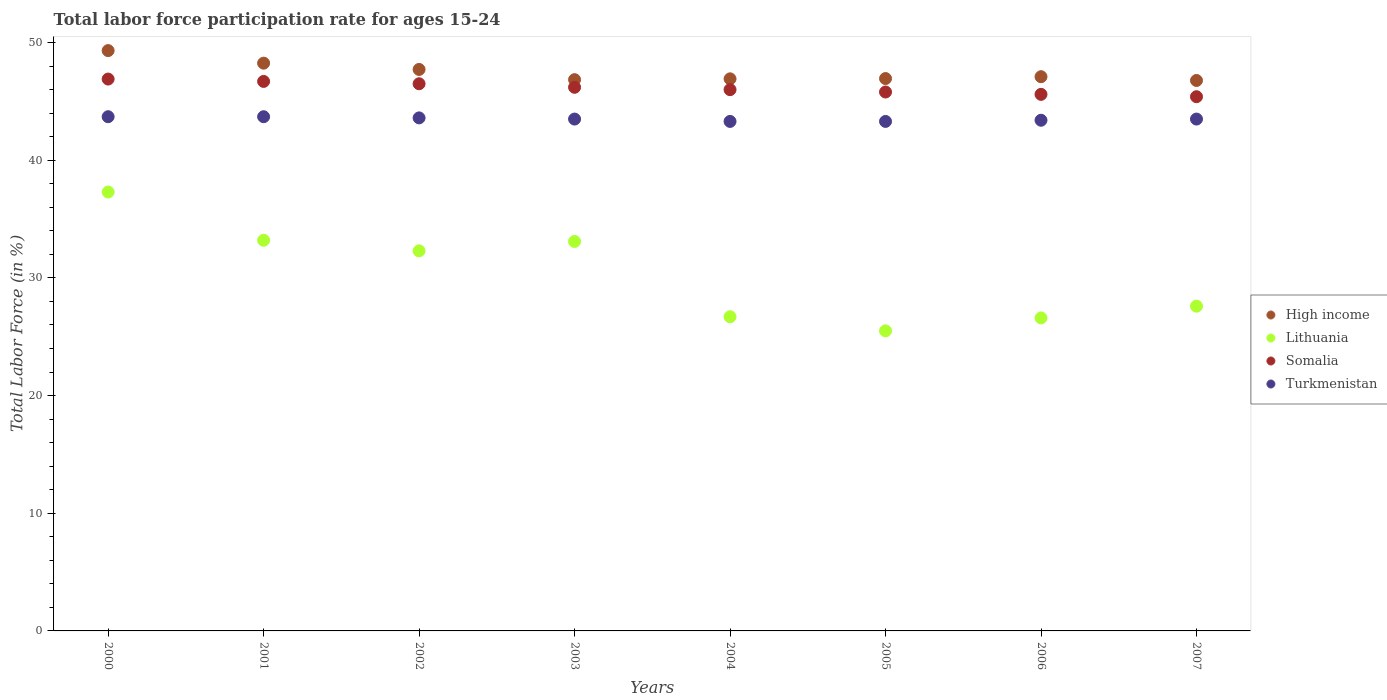Is the number of dotlines equal to the number of legend labels?
Your answer should be compact. Yes. What is the labor force participation rate in Turkmenistan in 2004?
Offer a terse response. 43.3. Across all years, what is the maximum labor force participation rate in Somalia?
Ensure brevity in your answer.  46.9. Across all years, what is the minimum labor force participation rate in Somalia?
Keep it short and to the point. 45.4. In which year was the labor force participation rate in Somalia maximum?
Ensure brevity in your answer.  2000. What is the total labor force participation rate in Lithuania in the graph?
Give a very brief answer. 242.3. What is the difference between the labor force participation rate in Lithuania in 2001 and that in 2003?
Offer a terse response. 0.1. What is the difference between the labor force participation rate in Lithuania in 2002 and the labor force participation rate in Turkmenistan in 2001?
Your response must be concise. -11.4. What is the average labor force participation rate in Somalia per year?
Give a very brief answer. 46.14. In the year 2002, what is the difference between the labor force participation rate in High income and labor force participation rate in Somalia?
Make the answer very short. 1.22. In how many years, is the labor force participation rate in High income greater than 10 %?
Keep it short and to the point. 8. What is the ratio of the labor force participation rate in Somalia in 2004 to that in 2005?
Keep it short and to the point. 1. Is the difference between the labor force participation rate in High income in 2000 and 2007 greater than the difference between the labor force participation rate in Somalia in 2000 and 2007?
Provide a succinct answer. Yes. What is the difference between the highest and the second highest labor force participation rate in Somalia?
Offer a terse response. 0.2. What is the difference between the highest and the lowest labor force participation rate in Somalia?
Keep it short and to the point. 1.5. In how many years, is the labor force participation rate in Lithuania greater than the average labor force participation rate in Lithuania taken over all years?
Provide a short and direct response. 4. Is the sum of the labor force participation rate in High income in 2004 and 2007 greater than the maximum labor force participation rate in Lithuania across all years?
Offer a terse response. Yes. Is it the case that in every year, the sum of the labor force participation rate in Somalia and labor force participation rate in Turkmenistan  is greater than the sum of labor force participation rate in Lithuania and labor force participation rate in High income?
Give a very brief answer. No. Is it the case that in every year, the sum of the labor force participation rate in High income and labor force participation rate in Turkmenistan  is greater than the labor force participation rate in Lithuania?
Make the answer very short. Yes. How many dotlines are there?
Give a very brief answer. 4. How many years are there in the graph?
Keep it short and to the point. 8. What is the difference between two consecutive major ticks on the Y-axis?
Provide a short and direct response. 10. How many legend labels are there?
Provide a succinct answer. 4. What is the title of the graph?
Your answer should be very brief. Total labor force participation rate for ages 15-24. What is the Total Labor Force (in %) of High income in 2000?
Give a very brief answer. 49.32. What is the Total Labor Force (in %) in Lithuania in 2000?
Keep it short and to the point. 37.3. What is the Total Labor Force (in %) in Somalia in 2000?
Your response must be concise. 46.9. What is the Total Labor Force (in %) in Turkmenistan in 2000?
Provide a succinct answer. 43.7. What is the Total Labor Force (in %) of High income in 2001?
Give a very brief answer. 48.25. What is the Total Labor Force (in %) of Lithuania in 2001?
Your response must be concise. 33.2. What is the Total Labor Force (in %) in Somalia in 2001?
Offer a very short reply. 46.7. What is the Total Labor Force (in %) in Turkmenistan in 2001?
Give a very brief answer. 43.7. What is the Total Labor Force (in %) in High income in 2002?
Your answer should be compact. 47.72. What is the Total Labor Force (in %) in Lithuania in 2002?
Your response must be concise. 32.3. What is the Total Labor Force (in %) of Somalia in 2002?
Provide a short and direct response. 46.5. What is the Total Labor Force (in %) in Turkmenistan in 2002?
Offer a terse response. 43.6. What is the Total Labor Force (in %) in High income in 2003?
Your answer should be very brief. 46.85. What is the Total Labor Force (in %) of Lithuania in 2003?
Your response must be concise. 33.1. What is the Total Labor Force (in %) of Somalia in 2003?
Keep it short and to the point. 46.2. What is the Total Labor Force (in %) of Turkmenistan in 2003?
Keep it short and to the point. 43.5. What is the Total Labor Force (in %) in High income in 2004?
Keep it short and to the point. 46.92. What is the Total Labor Force (in %) in Lithuania in 2004?
Offer a very short reply. 26.7. What is the Total Labor Force (in %) of Turkmenistan in 2004?
Your response must be concise. 43.3. What is the Total Labor Force (in %) of High income in 2005?
Make the answer very short. 46.94. What is the Total Labor Force (in %) of Lithuania in 2005?
Your answer should be very brief. 25.5. What is the Total Labor Force (in %) of Somalia in 2005?
Provide a succinct answer. 45.8. What is the Total Labor Force (in %) in Turkmenistan in 2005?
Your answer should be compact. 43.3. What is the Total Labor Force (in %) in High income in 2006?
Your answer should be very brief. 47.1. What is the Total Labor Force (in %) in Lithuania in 2006?
Ensure brevity in your answer.  26.6. What is the Total Labor Force (in %) of Somalia in 2006?
Your answer should be compact. 45.6. What is the Total Labor Force (in %) in Turkmenistan in 2006?
Ensure brevity in your answer.  43.4. What is the Total Labor Force (in %) of High income in 2007?
Your answer should be compact. 46.78. What is the Total Labor Force (in %) in Lithuania in 2007?
Offer a terse response. 27.6. What is the Total Labor Force (in %) in Somalia in 2007?
Your answer should be compact. 45.4. What is the Total Labor Force (in %) in Turkmenistan in 2007?
Keep it short and to the point. 43.5. Across all years, what is the maximum Total Labor Force (in %) of High income?
Ensure brevity in your answer.  49.32. Across all years, what is the maximum Total Labor Force (in %) of Lithuania?
Your answer should be very brief. 37.3. Across all years, what is the maximum Total Labor Force (in %) of Somalia?
Your answer should be very brief. 46.9. Across all years, what is the maximum Total Labor Force (in %) in Turkmenistan?
Offer a very short reply. 43.7. Across all years, what is the minimum Total Labor Force (in %) of High income?
Give a very brief answer. 46.78. Across all years, what is the minimum Total Labor Force (in %) in Lithuania?
Provide a short and direct response. 25.5. Across all years, what is the minimum Total Labor Force (in %) in Somalia?
Provide a short and direct response. 45.4. Across all years, what is the minimum Total Labor Force (in %) in Turkmenistan?
Provide a succinct answer. 43.3. What is the total Total Labor Force (in %) in High income in the graph?
Your response must be concise. 379.88. What is the total Total Labor Force (in %) of Lithuania in the graph?
Provide a short and direct response. 242.3. What is the total Total Labor Force (in %) in Somalia in the graph?
Make the answer very short. 369.1. What is the total Total Labor Force (in %) in Turkmenistan in the graph?
Your answer should be compact. 348. What is the difference between the Total Labor Force (in %) in High income in 2000 and that in 2001?
Make the answer very short. 1.07. What is the difference between the Total Labor Force (in %) in Lithuania in 2000 and that in 2001?
Make the answer very short. 4.1. What is the difference between the Total Labor Force (in %) in High income in 2000 and that in 2002?
Your answer should be very brief. 1.6. What is the difference between the Total Labor Force (in %) of Turkmenistan in 2000 and that in 2002?
Offer a very short reply. 0.1. What is the difference between the Total Labor Force (in %) in High income in 2000 and that in 2003?
Provide a short and direct response. 2.47. What is the difference between the Total Labor Force (in %) of Lithuania in 2000 and that in 2003?
Your answer should be compact. 4.2. What is the difference between the Total Labor Force (in %) in Turkmenistan in 2000 and that in 2003?
Make the answer very short. 0.2. What is the difference between the Total Labor Force (in %) in High income in 2000 and that in 2004?
Provide a succinct answer. 2.4. What is the difference between the Total Labor Force (in %) in Somalia in 2000 and that in 2004?
Ensure brevity in your answer.  0.9. What is the difference between the Total Labor Force (in %) in Turkmenistan in 2000 and that in 2004?
Ensure brevity in your answer.  0.4. What is the difference between the Total Labor Force (in %) of High income in 2000 and that in 2005?
Give a very brief answer. 2.38. What is the difference between the Total Labor Force (in %) in Lithuania in 2000 and that in 2005?
Give a very brief answer. 11.8. What is the difference between the Total Labor Force (in %) of Somalia in 2000 and that in 2005?
Ensure brevity in your answer.  1.1. What is the difference between the Total Labor Force (in %) of Turkmenistan in 2000 and that in 2005?
Ensure brevity in your answer.  0.4. What is the difference between the Total Labor Force (in %) of High income in 2000 and that in 2006?
Your answer should be compact. 2.22. What is the difference between the Total Labor Force (in %) of Turkmenistan in 2000 and that in 2006?
Your response must be concise. 0.3. What is the difference between the Total Labor Force (in %) of High income in 2000 and that in 2007?
Your answer should be compact. 2.54. What is the difference between the Total Labor Force (in %) of Lithuania in 2000 and that in 2007?
Keep it short and to the point. 9.7. What is the difference between the Total Labor Force (in %) of High income in 2001 and that in 2002?
Offer a very short reply. 0.53. What is the difference between the Total Labor Force (in %) of Lithuania in 2001 and that in 2002?
Your answer should be very brief. 0.9. What is the difference between the Total Labor Force (in %) in Turkmenistan in 2001 and that in 2002?
Offer a very short reply. 0.1. What is the difference between the Total Labor Force (in %) in High income in 2001 and that in 2003?
Provide a succinct answer. 1.4. What is the difference between the Total Labor Force (in %) of Somalia in 2001 and that in 2003?
Keep it short and to the point. 0.5. What is the difference between the Total Labor Force (in %) of High income in 2001 and that in 2004?
Your response must be concise. 1.33. What is the difference between the Total Labor Force (in %) of Lithuania in 2001 and that in 2004?
Your answer should be compact. 6.5. What is the difference between the Total Labor Force (in %) in Somalia in 2001 and that in 2004?
Give a very brief answer. 0.7. What is the difference between the Total Labor Force (in %) of Turkmenistan in 2001 and that in 2004?
Give a very brief answer. 0.4. What is the difference between the Total Labor Force (in %) in High income in 2001 and that in 2005?
Offer a very short reply. 1.31. What is the difference between the Total Labor Force (in %) of Lithuania in 2001 and that in 2005?
Offer a terse response. 7.7. What is the difference between the Total Labor Force (in %) in Somalia in 2001 and that in 2005?
Provide a succinct answer. 0.9. What is the difference between the Total Labor Force (in %) in High income in 2001 and that in 2006?
Keep it short and to the point. 1.15. What is the difference between the Total Labor Force (in %) in Lithuania in 2001 and that in 2006?
Provide a short and direct response. 6.6. What is the difference between the Total Labor Force (in %) in Somalia in 2001 and that in 2006?
Offer a very short reply. 1.1. What is the difference between the Total Labor Force (in %) in High income in 2001 and that in 2007?
Provide a short and direct response. 1.47. What is the difference between the Total Labor Force (in %) in High income in 2002 and that in 2003?
Ensure brevity in your answer.  0.87. What is the difference between the Total Labor Force (in %) of High income in 2002 and that in 2004?
Provide a succinct answer. 0.8. What is the difference between the Total Labor Force (in %) in Lithuania in 2002 and that in 2004?
Ensure brevity in your answer.  5.6. What is the difference between the Total Labor Force (in %) in High income in 2002 and that in 2005?
Provide a short and direct response. 0.77. What is the difference between the Total Labor Force (in %) in Turkmenistan in 2002 and that in 2005?
Offer a terse response. 0.3. What is the difference between the Total Labor Force (in %) of High income in 2002 and that in 2006?
Make the answer very short. 0.62. What is the difference between the Total Labor Force (in %) in Somalia in 2002 and that in 2006?
Provide a short and direct response. 0.9. What is the difference between the Total Labor Force (in %) in High income in 2002 and that in 2007?
Provide a succinct answer. 0.94. What is the difference between the Total Labor Force (in %) of Lithuania in 2002 and that in 2007?
Ensure brevity in your answer.  4.7. What is the difference between the Total Labor Force (in %) of Somalia in 2002 and that in 2007?
Keep it short and to the point. 1.1. What is the difference between the Total Labor Force (in %) of Turkmenistan in 2002 and that in 2007?
Provide a succinct answer. 0.1. What is the difference between the Total Labor Force (in %) of High income in 2003 and that in 2004?
Provide a short and direct response. -0.07. What is the difference between the Total Labor Force (in %) in Somalia in 2003 and that in 2004?
Offer a terse response. 0.2. What is the difference between the Total Labor Force (in %) in High income in 2003 and that in 2005?
Offer a terse response. -0.09. What is the difference between the Total Labor Force (in %) in Lithuania in 2003 and that in 2005?
Your response must be concise. 7.6. What is the difference between the Total Labor Force (in %) in Somalia in 2003 and that in 2005?
Your response must be concise. 0.4. What is the difference between the Total Labor Force (in %) of Turkmenistan in 2003 and that in 2005?
Give a very brief answer. 0.2. What is the difference between the Total Labor Force (in %) in High income in 2003 and that in 2006?
Offer a terse response. -0.25. What is the difference between the Total Labor Force (in %) of Somalia in 2003 and that in 2006?
Ensure brevity in your answer.  0.6. What is the difference between the Total Labor Force (in %) of High income in 2003 and that in 2007?
Your response must be concise. 0.07. What is the difference between the Total Labor Force (in %) in Lithuania in 2003 and that in 2007?
Give a very brief answer. 5.5. What is the difference between the Total Labor Force (in %) in Turkmenistan in 2003 and that in 2007?
Keep it short and to the point. 0. What is the difference between the Total Labor Force (in %) of High income in 2004 and that in 2005?
Your answer should be compact. -0.02. What is the difference between the Total Labor Force (in %) in High income in 2004 and that in 2006?
Your answer should be compact. -0.18. What is the difference between the Total Labor Force (in %) of Lithuania in 2004 and that in 2006?
Your answer should be very brief. 0.1. What is the difference between the Total Labor Force (in %) in High income in 2004 and that in 2007?
Make the answer very short. 0.14. What is the difference between the Total Labor Force (in %) of Turkmenistan in 2004 and that in 2007?
Provide a short and direct response. -0.2. What is the difference between the Total Labor Force (in %) in High income in 2005 and that in 2006?
Provide a short and direct response. -0.16. What is the difference between the Total Labor Force (in %) in High income in 2005 and that in 2007?
Give a very brief answer. 0.16. What is the difference between the Total Labor Force (in %) of Lithuania in 2005 and that in 2007?
Provide a succinct answer. -2.1. What is the difference between the Total Labor Force (in %) in Somalia in 2005 and that in 2007?
Offer a terse response. 0.4. What is the difference between the Total Labor Force (in %) in Turkmenistan in 2005 and that in 2007?
Provide a short and direct response. -0.2. What is the difference between the Total Labor Force (in %) in High income in 2006 and that in 2007?
Make the answer very short. 0.32. What is the difference between the Total Labor Force (in %) in High income in 2000 and the Total Labor Force (in %) in Lithuania in 2001?
Your answer should be very brief. 16.12. What is the difference between the Total Labor Force (in %) in High income in 2000 and the Total Labor Force (in %) in Somalia in 2001?
Your answer should be compact. 2.62. What is the difference between the Total Labor Force (in %) of High income in 2000 and the Total Labor Force (in %) of Turkmenistan in 2001?
Provide a short and direct response. 5.62. What is the difference between the Total Labor Force (in %) of Lithuania in 2000 and the Total Labor Force (in %) of Somalia in 2001?
Your response must be concise. -9.4. What is the difference between the Total Labor Force (in %) in Lithuania in 2000 and the Total Labor Force (in %) in Turkmenistan in 2001?
Ensure brevity in your answer.  -6.4. What is the difference between the Total Labor Force (in %) of Somalia in 2000 and the Total Labor Force (in %) of Turkmenistan in 2001?
Provide a succinct answer. 3.2. What is the difference between the Total Labor Force (in %) of High income in 2000 and the Total Labor Force (in %) of Lithuania in 2002?
Give a very brief answer. 17.02. What is the difference between the Total Labor Force (in %) in High income in 2000 and the Total Labor Force (in %) in Somalia in 2002?
Your answer should be compact. 2.82. What is the difference between the Total Labor Force (in %) of High income in 2000 and the Total Labor Force (in %) of Turkmenistan in 2002?
Offer a very short reply. 5.72. What is the difference between the Total Labor Force (in %) of Lithuania in 2000 and the Total Labor Force (in %) of Somalia in 2002?
Keep it short and to the point. -9.2. What is the difference between the Total Labor Force (in %) of Somalia in 2000 and the Total Labor Force (in %) of Turkmenistan in 2002?
Ensure brevity in your answer.  3.3. What is the difference between the Total Labor Force (in %) of High income in 2000 and the Total Labor Force (in %) of Lithuania in 2003?
Your answer should be very brief. 16.22. What is the difference between the Total Labor Force (in %) in High income in 2000 and the Total Labor Force (in %) in Somalia in 2003?
Ensure brevity in your answer.  3.12. What is the difference between the Total Labor Force (in %) of High income in 2000 and the Total Labor Force (in %) of Turkmenistan in 2003?
Give a very brief answer. 5.82. What is the difference between the Total Labor Force (in %) in Somalia in 2000 and the Total Labor Force (in %) in Turkmenistan in 2003?
Offer a very short reply. 3.4. What is the difference between the Total Labor Force (in %) in High income in 2000 and the Total Labor Force (in %) in Lithuania in 2004?
Your response must be concise. 22.62. What is the difference between the Total Labor Force (in %) of High income in 2000 and the Total Labor Force (in %) of Somalia in 2004?
Offer a terse response. 3.32. What is the difference between the Total Labor Force (in %) in High income in 2000 and the Total Labor Force (in %) in Turkmenistan in 2004?
Keep it short and to the point. 6.02. What is the difference between the Total Labor Force (in %) in Lithuania in 2000 and the Total Labor Force (in %) in Turkmenistan in 2004?
Provide a succinct answer. -6. What is the difference between the Total Labor Force (in %) in High income in 2000 and the Total Labor Force (in %) in Lithuania in 2005?
Your answer should be very brief. 23.82. What is the difference between the Total Labor Force (in %) in High income in 2000 and the Total Labor Force (in %) in Somalia in 2005?
Your response must be concise. 3.52. What is the difference between the Total Labor Force (in %) in High income in 2000 and the Total Labor Force (in %) in Turkmenistan in 2005?
Your response must be concise. 6.02. What is the difference between the Total Labor Force (in %) of Somalia in 2000 and the Total Labor Force (in %) of Turkmenistan in 2005?
Make the answer very short. 3.6. What is the difference between the Total Labor Force (in %) of High income in 2000 and the Total Labor Force (in %) of Lithuania in 2006?
Keep it short and to the point. 22.72. What is the difference between the Total Labor Force (in %) in High income in 2000 and the Total Labor Force (in %) in Somalia in 2006?
Provide a succinct answer. 3.72. What is the difference between the Total Labor Force (in %) of High income in 2000 and the Total Labor Force (in %) of Turkmenistan in 2006?
Provide a short and direct response. 5.92. What is the difference between the Total Labor Force (in %) of Lithuania in 2000 and the Total Labor Force (in %) of Turkmenistan in 2006?
Your response must be concise. -6.1. What is the difference between the Total Labor Force (in %) of Somalia in 2000 and the Total Labor Force (in %) of Turkmenistan in 2006?
Ensure brevity in your answer.  3.5. What is the difference between the Total Labor Force (in %) of High income in 2000 and the Total Labor Force (in %) of Lithuania in 2007?
Your response must be concise. 21.72. What is the difference between the Total Labor Force (in %) in High income in 2000 and the Total Labor Force (in %) in Somalia in 2007?
Provide a short and direct response. 3.92. What is the difference between the Total Labor Force (in %) of High income in 2000 and the Total Labor Force (in %) of Turkmenistan in 2007?
Provide a succinct answer. 5.82. What is the difference between the Total Labor Force (in %) in Lithuania in 2000 and the Total Labor Force (in %) in Turkmenistan in 2007?
Your response must be concise. -6.2. What is the difference between the Total Labor Force (in %) in High income in 2001 and the Total Labor Force (in %) in Lithuania in 2002?
Offer a very short reply. 15.95. What is the difference between the Total Labor Force (in %) in High income in 2001 and the Total Labor Force (in %) in Somalia in 2002?
Make the answer very short. 1.75. What is the difference between the Total Labor Force (in %) in High income in 2001 and the Total Labor Force (in %) in Turkmenistan in 2002?
Give a very brief answer. 4.65. What is the difference between the Total Labor Force (in %) in Somalia in 2001 and the Total Labor Force (in %) in Turkmenistan in 2002?
Ensure brevity in your answer.  3.1. What is the difference between the Total Labor Force (in %) of High income in 2001 and the Total Labor Force (in %) of Lithuania in 2003?
Keep it short and to the point. 15.15. What is the difference between the Total Labor Force (in %) of High income in 2001 and the Total Labor Force (in %) of Somalia in 2003?
Your response must be concise. 2.05. What is the difference between the Total Labor Force (in %) of High income in 2001 and the Total Labor Force (in %) of Turkmenistan in 2003?
Keep it short and to the point. 4.75. What is the difference between the Total Labor Force (in %) in High income in 2001 and the Total Labor Force (in %) in Lithuania in 2004?
Your answer should be very brief. 21.55. What is the difference between the Total Labor Force (in %) in High income in 2001 and the Total Labor Force (in %) in Somalia in 2004?
Keep it short and to the point. 2.25. What is the difference between the Total Labor Force (in %) of High income in 2001 and the Total Labor Force (in %) of Turkmenistan in 2004?
Ensure brevity in your answer.  4.95. What is the difference between the Total Labor Force (in %) of Lithuania in 2001 and the Total Labor Force (in %) of Somalia in 2004?
Ensure brevity in your answer.  -12.8. What is the difference between the Total Labor Force (in %) of Somalia in 2001 and the Total Labor Force (in %) of Turkmenistan in 2004?
Provide a succinct answer. 3.4. What is the difference between the Total Labor Force (in %) of High income in 2001 and the Total Labor Force (in %) of Lithuania in 2005?
Give a very brief answer. 22.75. What is the difference between the Total Labor Force (in %) of High income in 2001 and the Total Labor Force (in %) of Somalia in 2005?
Your answer should be compact. 2.45. What is the difference between the Total Labor Force (in %) in High income in 2001 and the Total Labor Force (in %) in Turkmenistan in 2005?
Offer a terse response. 4.95. What is the difference between the Total Labor Force (in %) in Lithuania in 2001 and the Total Labor Force (in %) in Somalia in 2005?
Your response must be concise. -12.6. What is the difference between the Total Labor Force (in %) of Lithuania in 2001 and the Total Labor Force (in %) of Turkmenistan in 2005?
Your answer should be compact. -10.1. What is the difference between the Total Labor Force (in %) of High income in 2001 and the Total Labor Force (in %) of Lithuania in 2006?
Your answer should be very brief. 21.65. What is the difference between the Total Labor Force (in %) in High income in 2001 and the Total Labor Force (in %) in Somalia in 2006?
Offer a very short reply. 2.65. What is the difference between the Total Labor Force (in %) in High income in 2001 and the Total Labor Force (in %) in Turkmenistan in 2006?
Your answer should be very brief. 4.85. What is the difference between the Total Labor Force (in %) in High income in 2001 and the Total Labor Force (in %) in Lithuania in 2007?
Offer a very short reply. 20.65. What is the difference between the Total Labor Force (in %) in High income in 2001 and the Total Labor Force (in %) in Somalia in 2007?
Provide a succinct answer. 2.85. What is the difference between the Total Labor Force (in %) in High income in 2001 and the Total Labor Force (in %) in Turkmenistan in 2007?
Provide a short and direct response. 4.75. What is the difference between the Total Labor Force (in %) in Lithuania in 2001 and the Total Labor Force (in %) in Somalia in 2007?
Offer a terse response. -12.2. What is the difference between the Total Labor Force (in %) in Lithuania in 2001 and the Total Labor Force (in %) in Turkmenistan in 2007?
Ensure brevity in your answer.  -10.3. What is the difference between the Total Labor Force (in %) in Somalia in 2001 and the Total Labor Force (in %) in Turkmenistan in 2007?
Your answer should be very brief. 3.2. What is the difference between the Total Labor Force (in %) in High income in 2002 and the Total Labor Force (in %) in Lithuania in 2003?
Offer a terse response. 14.62. What is the difference between the Total Labor Force (in %) in High income in 2002 and the Total Labor Force (in %) in Somalia in 2003?
Keep it short and to the point. 1.52. What is the difference between the Total Labor Force (in %) in High income in 2002 and the Total Labor Force (in %) in Turkmenistan in 2003?
Make the answer very short. 4.22. What is the difference between the Total Labor Force (in %) of Lithuania in 2002 and the Total Labor Force (in %) of Turkmenistan in 2003?
Ensure brevity in your answer.  -11.2. What is the difference between the Total Labor Force (in %) in Somalia in 2002 and the Total Labor Force (in %) in Turkmenistan in 2003?
Offer a very short reply. 3. What is the difference between the Total Labor Force (in %) in High income in 2002 and the Total Labor Force (in %) in Lithuania in 2004?
Ensure brevity in your answer.  21.02. What is the difference between the Total Labor Force (in %) in High income in 2002 and the Total Labor Force (in %) in Somalia in 2004?
Your response must be concise. 1.72. What is the difference between the Total Labor Force (in %) in High income in 2002 and the Total Labor Force (in %) in Turkmenistan in 2004?
Provide a succinct answer. 4.42. What is the difference between the Total Labor Force (in %) in Lithuania in 2002 and the Total Labor Force (in %) in Somalia in 2004?
Your answer should be very brief. -13.7. What is the difference between the Total Labor Force (in %) in High income in 2002 and the Total Labor Force (in %) in Lithuania in 2005?
Make the answer very short. 22.22. What is the difference between the Total Labor Force (in %) in High income in 2002 and the Total Labor Force (in %) in Somalia in 2005?
Provide a short and direct response. 1.92. What is the difference between the Total Labor Force (in %) of High income in 2002 and the Total Labor Force (in %) of Turkmenistan in 2005?
Offer a terse response. 4.42. What is the difference between the Total Labor Force (in %) of Lithuania in 2002 and the Total Labor Force (in %) of Somalia in 2005?
Your answer should be very brief. -13.5. What is the difference between the Total Labor Force (in %) of Somalia in 2002 and the Total Labor Force (in %) of Turkmenistan in 2005?
Your answer should be compact. 3.2. What is the difference between the Total Labor Force (in %) in High income in 2002 and the Total Labor Force (in %) in Lithuania in 2006?
Give a very brief answer. 21.12. What is the difference between the Total Labor Force (in %) in High income in 2002 and the Total Labor Force (in %) in Somalia in 2006?
Your answer should be very brief. 2.12. What is the difference between the Total Labor Force (in %) in High income in 2002 and the Total Labor Force (in %) in Turkmenistan in 2006?
Provide a succinct answer. 4.32. What is the difference between the Total Labor Force (in %) of Lithuania in 2002 and the Total Labor Force (in %) of Turkmenistan in 2006?
Your answer should be compact. -11.1. What is the difference between the Total Labor Force (in %) in Somalia in 2002 and the Total Labor Force (in %) in Turkmenistan in 2006?
Give a very brief answer. 3.1. What is the difference between the Total Labor Force (in %) in High income in 2002 and the Total Labor Force (in %) in Lithuania in 2007?
Keep it short and to the point. 20.12. What is the difference between the Total Labor Force (in %) of High income in 2002 and the Total Labor Force (in %) of Somalia in 2007?
Offer a very short reply. 2.32. What is the difference between the Total Labor Force (in %) of High income in 2002 and the Total Labor Force (in %) of Turkmenistan in 2007?
Provide a succinct answer. 4.22. What is the difference between the Total Labor Force (in %) of Lithuania in 2002 and the Total Labor Force (in %) of Turkmenistan in 2007?
Keep it short and to the point. -11.2. What is the difference between the Total Labor Force (in %) of Somalia in 2002 and the Total Labor Force (in %) of Turkmenistan in 2007?
Give a very brief answer. 3. What is the difference between the Total Labor Force (in %) of High income in 2003 and the Total Labor Force (in %) of Lithuania in 2004?
Your response must be concise. 20.15. What is the difference between the Total Labor Force (in %) of High income in 2003 and the Total Labor Force (in %) of Somalia in 2004?
Keep it short and to the point. 0.85. What is the difference between the Total Labor Force (in %) in High income in 2003 and the Total Labor Force (in %) in Turkmenistan in 2004?
Offer a very short reply. 3.55. What is the difference between the Total Labor Force (in %) of Lithuania in 2003 and the Total Labor Force (in %) of Somalia in 2004?
Offer a very short reply. -12.9. What is the difference between the Total Labor Force (in %) in High income in 2003 and the Total Labor Force (in %) in Lithuania in 2005?
Offer a terse response. 21.35. What is the difference between the Total Labor Force (in %) in High income in 2003 and the Total Labor Force (in %) in Somalia in 2005?
Your answer should be very brief. 1.05. What is the difference between the Total Labor Force (in %) in High income in 2003 and the Total Labor Force (in %) in Turkmenistan in 2005?
Offer a terse response. 3.55. What is the difference between the Total Labor Force (in %) in Lithuania in 2003 and the Total Labor Force (in %) in Turkmenistan in 2005?
Make the answer very short. -10.2. What is the difference between the Total Labor Force (in %) of High income in 2003 and the Total Labor Force (in %) of Lithuania in 2006?
Make the answer very short. 20.25. What is the difference between the Total Labor Force (in %) of High income in 2003 and the Total Labor Force (in %) of Somalia in 2006?
Your answer should be very brief. 1.25. What is the difference between the Total Labor Force (in %) in High income in 2003 and the Total Labor Force (in %) in Turkmenistan in 2006?
Give a very brief answer. 3.45. What is the difference between the Total Labor Force (in %) in Somalia in 2003 and the Total Labor Force (in %) in Turkmenistan in 2006?
Your answer should be very brief. 2.8. What is the difference between the Total Labor Force (in %) of High income in 2003 and the Total Labor Force (in %) of Lithuania in 2007?
Your answer should be compact. 19.25. What is the difference between the Total Labor Force (in %) of High income in 2003 and the Total Labor Force (in %) of Somalia in 2007?
Provide a succinct answer. 1.45. What is the difference between the Total Labor Force (in %) of High income in 2003 and the Total Labor Force (in %) of Turkmenistan in 2007?
Ensure brevity in your answer.  3.35. What is the difference between the Total Labor Force (in %) in Lithuania in 2003 and the Total Labor Force (in %) in Turkmenistan in 2007?
Your response must be concise. -10.4. What is the difference between the Total Labor Force (in %) of Somalia in 2003 and the Total Labor Force (in %) of Turkmenistan in 2007?
Offer a very short reply. 2.7. What is the difference between the Total Labor Force (in %) in High income in 2004 and the Total Labor Force (in %) in Lithuania in 2005?
Your answer should be compact. 21.42. What is the difference between the Total Labor Force (in %) in High income in 2004 and the Total Labor Force (in %) in Somalia in 2005?
Your answer should be very brief. 1.12. What is the difference between the Total Labor Force (in %) of High income in 2004 and the Total Labor Force (in %) of Turkmenistan in 2005?
Ensure brevity in your answer.  3.62. What is the difference between the Total Labor Force (in %) in Lithuania in 2004 and the Total Labor Force (in %) in Somalia in 2005?
Provide a succinct answer. -19.1. What is the difference between the Total Labor Force (in %) of Lithuania in 2004 and the Total Labor Force (in %) of Turkmenistan in 2005?
Make the answer very short. -16.6. What is the difference between the Total Labor Force (in %) in High income in 2004 and the Total Labor Force (in %) in Lithuania in 2006?
Provide a short and direct response. 20.32. What is the difference between the Total Labor Force (in %) of High income in 2004 and the Total Labor Force (in %) of Somalia in 2006?
Make the answer very short. 1.32. What is the difference between the Total Labor Force (in %) of High income in 2004 and the Total Labor Force (in %) of Turkmenistan in 2006?
Offer a very short reply. 3.52. What is the difference between the Total Labor Force (in %) in Lithuania in 2004 and the Total Labor Force (in %) in Somalia in 2006?
Keep it short and to the point. -18.9. What is the difference between the Total Labor Force (in %) of Lithuania in 2004 and the Total Labor Force (in %) of Turkmenistan in 2006?
Offer a terse response. -16.7. What is the difference between the Total Labor Force (in %) in Somalia in 2004 and the Total Labor Force (in %) in Turkmenistan in 2006?
Your answer should be very brief. 2.6. What is the difference between the Total Labor Force (in %) of High income in 2004 and the Total Labor Force (in %) of Lithuania in 2007?
Make the answer very short. 19.32. What is the difference between the Total Labor Force (in %) in High income in 2004 and the Total Labor Force (in %) in Somalia in 2007?
Keep it short and to the point. 1.52. What is the difference between the Total Labor Force (in %) in High income in 2004 and the Total Labor Force (in %) in Turkmenistan in 2007?
Keep it short and to the point. 3.42. What is the difference between the Total Labor Force (in %) in Lithuania in 2004 and the Total Labor Force (in %) in Somalia in 2007?
Your answer should be very brief. -18.7. What is the difference between the Total Labor Force (in %) in Lithuania in 2004 and the Total Labor Force (in %) in Turkmenistan in 2007?
Ensure brevity in your answer.  -16.8. What is the difference between the Total Labor Force (in %) in High income in 2005 and the Total Labor Force (in %) in Lithuania in 2006?
Provide a succinct answer. 20.34. What is the difference between the Total Labor Force (in %) of High income in 2005 and the Total Labor Force (in %) of Somalia in 2006?
Ensure brevity in your answer.  1.34. What is the difference between the Total Labor Force (in %) of High income in 2005 and the Total Labor Force (in %) of Turkmenistan in 2006?
Make the answer very short. 3.54. What is the difference between the Total Labor Force (in %) in Lithuania in 2005 and the Total Labor Force (in %) in Somalia in 2006?
Provide a succinct answer. -20.1. What is the difference between the Total Labor Force (in %) in Lithuania in 2005 and the Total Labor Force (in %) in Turkmenistan in 2006?
Provide a short and direct response. -17.9. What is the difference between the Total Labor Force (in %) in High income in 2005 and the Total Labor Force (in %) in Lithuania in 2007?
Ensure brevity in your answer.  19.34. What is the difference between the Total Labor Force (in %) in High income in 2005 and the Total Labor Force (in %) in Somalia in 2007?
Offer a terse response. 1.54. What is the difference between the Total Labor Force (in %) in High income in 2005 and the Total Labor Force (in %) in Turkmenistan in 2007?
Provide a short and direct response. 3.44. What is the difference between the Total Labor Force (in %) of Lithuania in 2005 and the Total Labor Force (in %) of Somalia in 2007?
Provide a succinct answer. -19.9. What is the difference between the Total Labor Force (in %) in Somalia in 2005 and the Total Labor Force (in %) in Turkmenistan in 2007?
Ensure brevity in your answer.  2.3. What is the difference between the Total Labor Force (in %) in High income in 2006 and the Total Labor Force (in %) in Lithuania in 2007?
Offer a terse response. 19.5. What is the difference between the Total Labor Force (in %) in High income in 2006 and the Total Labor Force (in %) in Somalia in 2007?
Offer a very short reply. 1.7. What is the difference between the Total Labor Force (in %) of High income in 2006 and the Total Labor Force (in %) of Turkmenistan in 2007?
Make the answer very short. 3.6. What is the difference between the Total Labor Force (in %) in Lithuania in 2006 and the Total Labor Force (in %) in Somalia in 2007?
Ensure brevity in your answer.  -18.8. What is the difference between the Total Labor Force (in %) of Lithuania in 2006 and the Total Labor Force (in %) of Turkmenistan in 2007?
Give a very brief answer. -16.9. What is the average Total Labor Force (in %) in High income per year?
Offer a very short reply. 47.48. What is the average Total Labor Force (in %) of Lithuania per year?
Make the answer very short. 30.29. What is the average Total Labor Force (in %) in Somalia per year?
Make the answer very short. 46.14. What is the average Total Labor Force (in %) in Turkmenistan per year?
Offer a very short reply. 43.5. In the year 2000, what is the difference between the Total Labor Force (in %) of High income and Total Labor Force (in %) of Lithuania?
Ensure brevity in your answer.  12.02. In the year 2000, what is the difference between the Total Labor Force (in %) of High income and Total Labor Force (in %) of Somalia?
Ensure brevity in your answer.  2.42. In the year 2000, what is the difference between the Total Labor Force (in %) of High income and Total Labor Force (in %) of Turkmenistan?
Provide a short and direct response. 5.62. In the year 2000, what is the difference between the Total Labor Force (in %) of Lithuania and Total Labor Force (in %) of Turkmenistan?
Offer a terse response. -6.4. In the year 2000, what is the difference between the Total Labor Force (in %) of Somalia and Total Labor Force (in %) of Turkmenistan?
Provide a succinct answer. 3.2. In the year 2001, what is the difference between the Total Labor Force (in %) in High income and Total Labor Force (in %) in Lithuania?
Your answer should be compact. 15.05. In the year 2001, what is the difference between the Total Labor Force (in %) of High income and Total Labor Force (in %) of Somalia?
Provide a succinct answer. 1.55. In the year 2001, what is the difference between the Total Labor Force (in %) in High income and Total Labor Force (in %) in Turkmenistan?
Offer a terse response. 4.55. In the year 2001, what is the difference between the Total Labor Force (in %) in Lithuania and Total Labor Force (in %) in Turkmenistan?
Your response must be concise. -10.5. In the year 2001, what is the difference between the Total Labor Force (in %) of Somalia and Total Labor Force (in %) of Turkmenistan?
Your response must be concise. 3. In the year 2002, what is the difference between the Total Labor Force (in %) in High income and Total Labor Force (in %) in Lithuania?
Your response must be concise. 15.42. In the year 2002, what is the difference between the Total Labor Force (in %) in High income and Total Labor Force (in %) in Somalia?
Give a very brief answer. 1.22. In the year 2002, what is the difference between the Total Labor Force (in %) of High income and Total Labor Force (in %) of Turkmenistan?
Make the answer very short. 4.12. In the year 2003, what is the difference between the Total Labor Force (in %) in High income and Total Labor Force (in %) in Lithuania?
Make the answer very short. 13.75. In the year 2003, what is the difference between the Total Labor Force (in %) in High income and Total Labor Force (in %) in Somalia?
Provide a short and direct response. 0.65. In the year 2003, what is the difference between the Total Labor Force (in %) in High income and Total Labor Force (in %) in Turkmenistan?
Offer a terse response. 3.35. In the year 2003, what is the difference between the Total Labor Force (in %) in Lithuania and Total Labor Force (in %) in Somalia?
Ensure brevity in your answer.  -13.1. In the year 2003, what is the difference between the Total Labor Force (in %) of Lithuania and Total Labor Force (in %) of Turkmenistan?
Provide a succinct answer. -10.4. In the year 2003, what is the difference between the Total Labor Force (in %) of Somalia and Total Labor Force (in %) of Turkmenistan?
Your answer should be very brief. 2.7. In the year 2004, what is the difference between the Total Labor Force (in %) of High income and Total Labor Force (in %) of Lithuania?
Give a very brief answer. 20.22. In the year 2004, what is the difference between the Total Labor Force (in %) in High income and Total Labor Force (in %) in Somalia?
Give a very brief answer. 0.92. In the year 2004, what is the difference between the Total Labor Force (in %) of High income and Total Labor Force (in %) of Turkmenistan?
Provide a short and direct response. 3.62. In the year 2004, what is the difference between the Total Labor Force (in %) in Lithuania and Total Labor Force (in %) in Somalia?
Offer a terse response. -19.3. In the year 2004, what is the difference between the Total Labor Force (in %) of Lithuania and Total Labor Force (in %) of Turkmenistan?
Make the answer very short. -16.6. In the year 2005, what is the difference between the Total Labor Force (in %) of High income and Total Labor Force (in %) of Lithuania?
Your answer should be very brief. 21.44. In the year 2005, what is the difference between the Total Labor Force (in %) of High income and Total Labor Force (in %) of Somalia?
Offer a very short reply. 1.14. In the year 2005, what is the difference between the Total Labor Force (in %) of High income and Total Labor Force (in %) of Turkmenistan?
Give a very brief answer. 3.64. In the year 2005, what is the difference between the Total Labor Force (in %) of Lithuania and Total Labor Force (in %) of Somalia?
Your answer should be compact. -20.3. In the year 2005, what is the difference between the Total Labor Force (in %) of Lithuania and Total Labor Force (in %) of Turkmenistan?
Ensure brevity in your answer.  -17.8. In the year 2006, what is the difference between the Total Labor Force (in %) in High income and Total Labor Force (in %) in Lithuania?
Your answer should be compact. 20.5. In the year 2006, what is the difference between the Total Labor Force (in %) in High income and Total Labor Force (in %) in Somalia?
Provide a short and direct response. 1.5. In the year 2006, what is the difference between the Total Labor Force (in %) in High income and Total Labor Force (in %) in Turkmenistan?
Your response must be concise. 3.7. In the year 2006, what is the difference between the Total Labor Force (in %) in Lithuania and Total Labor Force (in %) in Somalia?
Offer a terse response. -19. In the year 2006, what is the difference between the Total Labor Force (in %) in Lithuania and Total Labor Force (in %) in Turkmenistan?
Keep it short and to the point. -16.8. In the year 2006, what is the difference between the Total Labor Force (in %) in Somalia and Total Labor Force (in %) in Turkmenistan?
Keep it short and to the point. 2.2. In the year 2007, what is the difference between the Total Labor Force (in %) in High income and Total Labor Force (in %) in Lithuania?
Ensure brevity in your answer.  19.18. In the year 2007, what is the difference between the Total Labor Force (in %) of High income and Total Labor Force (in %) of Somalia?
Your answer should be compact. 1.38. In the year 2007, what is the difference between the Total Labor Force (in %) in High income and Total Labor Force (in %) in Turkmenistan?
Offer a very short reply. 3.28. In the year 2007, what is the difference between the Total Labor Force (in %) of Lithuania and Total Labor Force (in %) of Somalia?
Keep it short and to the point. -17.8. In the year 2007, what is the difference between the Total Labor Force (in %) of Lithuania and Total Labor Force (in %) of Turkmenistan?
Your answer should be very brief. -15.9. What is the ratio of the Total Labor Force (in %) in High income in 2000 to that in 2001?
Your answer should be very brief. 1.02. What is the ratio of the Total Labor Force (in %) of Lithuania in 2000 to that in 2001?
Provide a succinct answer. 1.12. What is the ratio of the Total Labor Force (in %) in Somalia in 2000 to that in 2001?
Give a very brief answer. 1. What is the ratio of the Total Labor Force (in %) in Turkmenistan in 2000 to that in 2001?
Provide a succinct answer. 1. What is the ratio of the Total Labor Force (in %) in High income in 2000 to that in 2002?
Make the answer very short. 1.03. What is the ratio of the Total Labor Force (in %) in Lithuania in 2000 to that in 2002?
Your answer should be compact. 1.15. What is the ratio of the Total Labor Force (in %) of Somalia in 2000 to that in 2002?
Make the answer very short. 1.01. What is the ratio of the Total Labor Force (in %) in Turkmenistan in 2000 to that in 2002?
Give a very brief answer. 1. What is the ratio of the Total Labor Force (in %) of High income in 2000 to that in 2003?
Give a very brief answer. 1.05. What is the ratio of the Total Labor Force (in %) in Lithuania in 2000 to that in 2003?
Your answer should be compact. 1.13. What is the ratio of the Total Labor Force (in %) of Somalia in 2000 to that in 2003?
Your answer should be compact. 1.02. What is the ratio of the Total Labor Force (in %) in Turkmenistan in 2000 to that in 2003?
Your response must be concise. 1. What is the ratio of the Total Labor Force (in %) of High income in 2000 to that in 2004?
Give a very brief answer. 1.05. What is the ratio of the Total Labor Force (in %) of Lithuania in 2000 to that in 2004?
Provide a short and direct response. 1.4. What is the ratio of the Total Labor Force (in %) in Somalia in 2000 to that in 2004?
Ensure brevity in your answer.  1.02. What is the ratio of the Total Labor Force (in %) in Turkmenistan in 2000 to that in 2004?
Ensure brevity in your answer.  1.01. What is the ratio of the Total Labor Force (in %) of High income in 2000 to that in 2005?
Provide a short and direct response. 1.05. What is the ratio of the Total Labor Force (in %) of Lithuania in 2000 to that in 2005?
Offer a terse response. 1.46. What is the ratio of the Total Labor Force (in %) in Turkmenistan in 2000 to that in 2005?
Make the answer very short. 1.01. What is the ratio of the Total Labor Force (in %) in High income in 2000 to that in 2006?
Your answer should be very brief. 1.05. What is the ratio of the Total Labor Force (in %) in Lithuania in 2000 to that in 2006?
Keep it short and to the point. 1.4. What is the ratio of the Total Labor Force (in %) in Somalia in 2000 to that in 2006?
Provide a succinct answer. 1.03. What is the ratio of the Total Labor Force (in %) of High income in 2000 to that in 2007?
Offer a very short reply. 1.05. What is the ratio of the Total Labor Force (in %) in Lithuania in 2000 to that in 2007?
Provide a succinct answer. 1.35. What is the ratio of the Total Labor Force (in %) in Somalia in 2000 to that in 2007?
Your answer should be compact. 1.03. What is the ratio of the Total Labor Force (in %) of Turkmenistan in 2000 to that in 2007?
Offer a terse response. 1. What is the ratio of the Total Labor Force (in %) in High income in 2001 to that in 2002?
Keep it short and to the point. 1.01. What is the ratio of the Total Labor Force (in %) of Lithuania in 2001 to that in 2002?
Keep it short and to the point. 1.03. What is the ratio of the Total Labor Force (in %) in High income in 2001 to that in 2003?
Your response must be concise. 1.03. What is the ratio of the Total Labor Force (in %) of Lithuania in 2001 to that in 2003?
Make the answer very short. 1. What is the ratio of the Total Labor Force (in %) in Somalia in 2001 to that in 2003?
Give a very brief answer. 1.01. What is the ratio of the Total Labor Force (in %) in High income in 2001 to that in 2004?
Offer a very short reply. 1.03. What is the ratio of the Total Labor Force (in %) of Lithuania in 2001 to that in 2004?
Offer a terse response. 1.24. What is the ratio of the Total Labor Force (in %) in Somalia in 2001 to that in 2004?
Ensure brevity in your answer.  1.02. What is the ratio of the Total Labor Force (in %) of Turkmenistan in 2001 to that in 2004?
Provide a succinct answer. 1.01. What is the ratio of the Total Labor Force (in %) in High income in 2001 to that in 2005?
Make the answer very short. 1.03. What is the ratio of the Total Labor Force (in %) of Lithuania in 2001 to that in 2005?
Give a very brief answer. 1.3. What is the ratio of the Total Labor Force (in %) in Somalia in 2001 to that in 2005?
Offer a very short reply. 1.02. What is the ratio of the Total Labor Force (in %) of Turkmenistan in 2001 to that in 2005?
Offer a terse response. 1.01. What is the ratio of the Total Labor Force (in %) of High income in 2001 to that in 2006?
Give a very brief answer. 1.02. What is the ratio of the Total Labor Force (in %) in Lithuania in 2001 to that in 2006?
Your answer should be very brief. 1.25. What is the ratio of the Total Labor Force (in %) in Somalia in 2001 to that in 2006?
Keep it short and to the point. 1.02. What is the ratio of the Total Labor Force (in %) in Turkmenistan in 2001 to that in 2006?
Offer a very short reply. 1.01. What is the ratio of the Total Labor Force (in %) in High income in 2001 to that in 2007?
Offer a terse response. 1.03. What is the ratio of the Total Labor Force (in %) of Lithuania in 2001 to that in 2007?
Provide a succinct answer. 1.2. What is the ratio of the Total Labor Force (in %) in Somalia in 2001 to that in 2007?
Offer a terse response. 1.03. What is the ratio of the Total Labor Force (in %) of High income in 2002 to that in 2003?
Make the answer very short. 1.02. What is the ratio of the Total Labor Force (in %) of Lithuania in 2002 to that in 2003?
Keep it short and to the point. 0.98. What is the ratio of the Total Labor Force (in %) of Turkmenistan in 2002 to that in 2003?
Offer a terse response. 1. What is the ratio of the Total Labor Force (in %) in High income in 2002 to that in 2004?
Your answer should be very brief. 1.02. What is the ratio of the Total Labor Force (in %) of Lithuania in 2002 to that in 2004?
Offer a terse response. 1.21. What is the ratio of the Total Labor Force (in %) of Somalia in 2002 to that in 2004?
Make the answer very short. 1.01. What is the ratio of the Total Labor Force (in %) in Turkmenistan in 2002 to that in 2004?
Make the answer very short. 1.01. What is the ratio of the Total Labor Force (in %) of High income in 2002 to that in 2005?
Offer a terse response. 1.02. What is the ratio of the Total Labor Force (in %) in Lithuania in 2002 to that in 2005?
Your answer should be very brief. 1.27. What is the ratio of the Total Labor Force (in %) in Somalia in 2002 to that in 2005?
Offer a terse response. 1.02. What is the ratio of the Total Labor Force (in %) in High income in 2002 to that in 2006?
Offer a terse response. 1.01. What is the ratio of the Total Labor Force (in %) of Lithuania in 2002 to that in 2006?
Provide a short and direct response. 1.21. What is the ratio of the Total Labor Force (in %) of Somalia in 2002 to that in 2006?
Your answer should be very brief. 1.02. What is the ratio of the Total Labor Force (in %) of Turkmenistan in 2002 to that in 2006?
Make the answer very short. 1. What is the ratio of the Total Labor Force (in %) in Lithuania in 2002 to that in 2007?
Provide a short and direct response. 1.17. What is the ratio of the Total Labor Force (in %) in Somalia in 2002 to that in 2007?
Your answer should be compact. 1.02. What is the ratio of the Total Labor Force (in %) of Turkmenistan in 2002 to that in 2007?
Your answer should be very brief. 1. What is the ratio of the Total Labor Force (in %) of Lithuania in 2003 to that in 2004?
Offer a very short reply. 1.24. What is the ratio of the Total Labor Force (in %) in Somalia in 2003 to that in 2004?
Give a very brief answer. 1. What is the ratio of the Total Labor Force (in %) of High income in 2003 to that in 2005?
Your answer should be compact. 1. What is the ratio of the Total Labor Force (in %) in Lithuania in 2003 to that in 2005?
Make the answer very short. 1.3. What is the ratio of the Total Labor Force (in %) in Somalia in 2003 to that in 2005?
Provide a succinct answer. 1.01. What is the ratio of the Total Labor Force (in %) of Turkmenistan in 2003 to that in 2005?
Provide a short and direct response. 1. What is the ratio of the Total Labor Force (in %) in Lithuania in 2003 to that in 2006?
Your answer should be very brief. 1.24. What is the ratio of the Total Labor Force (in %) of Somalia in 2003 to that in 2006?
Provide a succinct answer. 1.01. What is the ratio of the Total Labor Force (in %) in Turkmenistan in 2003 to that in 2006?
Offer a very short reply. 1. What is the ratio of the Total Labor Force (in %) of Lithuania in 2003 to that in 2007?
Your response must be concise. 1.2. What is the ratio of the Total Labor Force (in %) in Somalia in 2003 to that in 2007?
Ensure brevity in your answer.  1.02. What is the ratio of the Total Labor Force (in %) of High income in 2004 to that in 2005?
Offer a very short reply. 1. What is the ratio of the Total Labor Force (in %) in Lithuania in 2004 to that in 2005?
Provide a short and direct response. 1.05. What is the ratio of the Total Labor Force (in %) in Turkmenistan in 2004 to that in 2005?
Your response must be concise. 1. What is the ratio of the Total Labor Force (in %) of Lithuania in 2004 to that in 2006?
Offer a terse response. 1. What is the ratio of the Total Labor Force (in %) of Somalia in 2004 to that in 2006?
Your answer should be compact. 1.01. What is the ratio of the Total Labor Force (in %) of Lithuania in 2004 to that in 2007?
Your answer should be compact. 0.97. What is the ratio of the Total Labor Force (in %) in Somalia in 2004 to that in 2007?
Offer a very short reply. 1.01. What is the ratio of the Total Labor Force (in %) in Turkmenistan in 2004 to that in 2007?
Offer a terse response. 1. What is the ratio of the Total Labor Force (in %) in Lithuania in 2005 to that in 2006?
Offer a terse response. 0.96. What is the ratio of the Total Labor Force (in %) in Somalia in 2005 to that in 2006?
Offer a terse response. 1. What is the ratio of the Total Labor Force (in %) in Lithuania in 2005 to that in 2007?
Offer a very short reply. 0.92. What is the ratio of the Total Labor Force (in %) in Somalia in 2005 to that in 2007?
Offer a very short reply. 1.01. What is the ratio of the Total Labor Force (in %) of Lithuania in 2006 to that in 2007?
Give a very brief answer. 0.96. What is the ratio of the Total Labor Force (in %) in Turkmenistan in 2006 to that in 2007?
Your answer should be very brief. 1. What is the difference between the highest and the second highest Total Labor Force (in %) of High income?
Your answer should be compact. 1.07. What is the difference between the highest and the second highest Total Labor Force (in %) of Lithuania?
Your answer should be very brief. 4.1. What is the difference between the highest and the second highest Total Labor Force (in %) in Somalia?
Your response must be concise. 0.2. What is the difference between the highest and the lowest Total Labor Force (in %) in High income?
Provide a short and direct response. 2.54. What is the difference between the highest and the lowest Total Labor Force (in %) of Lithuania?
Offer a terse response. 11.8. What is the difference between the highest and the lowest Total Labor Force (in %) in Somalia?
Ensure brevity in your answer.  1.5. What is the difference between the highest and the lowest Total Labor Force (in %) of Turkmenistan?
Make the answer very short. 0.4. 